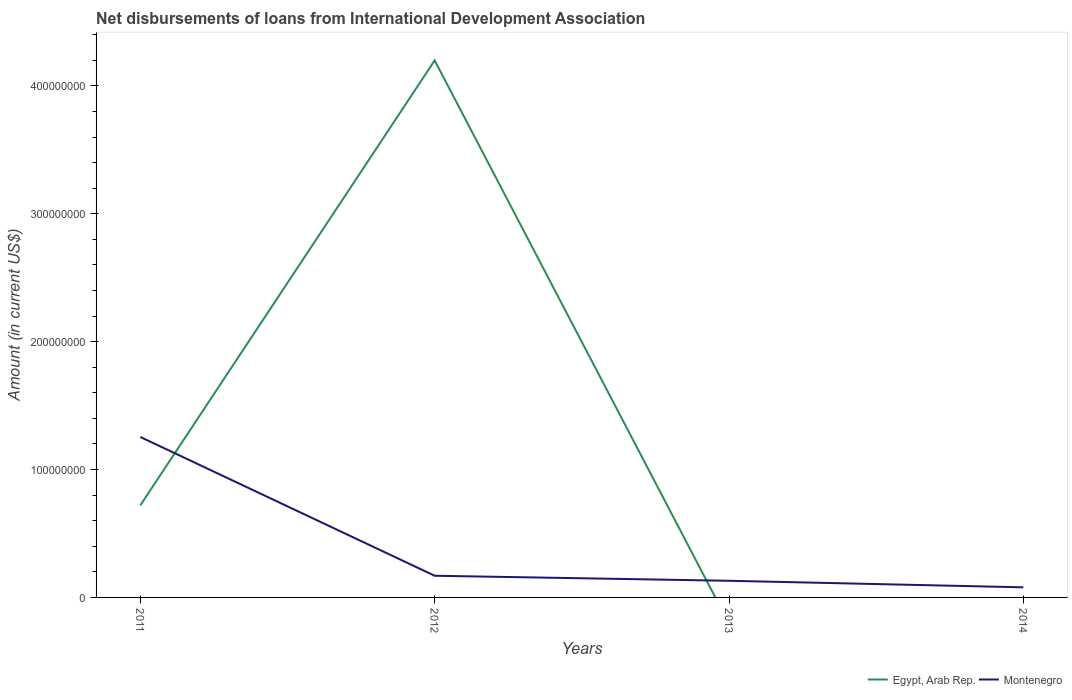How many different coloured lines are there?
Ensure brevity in your answer.  2. Does the line corresponding to Egypt, Arab Rep. intersect with the line corresponding to Montenegro?
Offer a terse response. Yes. What is the total amount of loans disbursed in Montenegro in the graph?
Your response must be concise. 5.12e+06. What is the difference between the highest and the second highest amount of loans disbursed in Egypt, Arab Rep.?
Offer a very short reply. 4.20e+08. Is the amount of loans disbursed in Montenegro strictly greater than the amount of loans disbursed in Egypt, Arab Rep. over the years?
Offer a very short reply. No. How many years are there in the graph?
Your response must be concise. 4. What is the difference between two consecutive major ticks on the Y-axis?
Your answer should be very brief. 1.00e+08. Are the values on the major ticks of Y-axis written in scientific E-notation?
Your response must be concise. No. How are the legend labels stacked?
Offer a very short reply. Horizontal. What is the title of the graph?
Your answer should be very brief. Net disbursements of loans from International Development Association. Does "Spain" appear as one of the legend labels in the graph?
Keep it short and to the point. No. What is the label or title of the Y-axis?
Provide a short and direct response. Amount (in current US$). What is the Amount (in current US$) in Egypt, Arab Rep. in 2011?
Make the answer very short. 7.20e+07. What is the Amount (in current US$) in Montenegro in 2011?
Your response must be concise. 1.25e+08. What is the Amount (in current US$) of Egypt, Arab Rep. in 2012?
Your answer should be very brief. 4.20e+08. What is the Amount (in current US$) in Montenegro in 2012?
Offer a terse response. 1.70e+07. What is the Amount (in current US$) in Egypt, Arab Rep. in 2013?
Keep it short and to the point. 0. What is the Amount (in current US$) in Montenegro in 2013?
Offer a very short reply. 1.30e+07. What is the Amount (in current US$) in Egypt, Arab Rep. in 2014?
Provide a succinct answer. 0. What is the Amount (in current US$) of Montenegro in 2014?
Provide a succinct answer. 7.89e+06. Across all years, what is the maximum Amount (in current US$) of Egypt, Arab Rep.?
Ensure brevity in your answer.  4.20e+08. Across all years, what is the maximum Amount (in current US$) of Montenegro?
Provide a succinct answer. 1.25e+08. Across all years, what is the minimum Amount (in current US$) of Montenegro?
Offer a terse response. 7.89e+06. What is the total Amount (in current US$) of Egypt, Arab Rep. in the graph?
Provide a short and direct response. 4.92e+08. What is the total Amount (in current US$) of Montenegro in the graph?
Ensure brevity in your answer.  1.63e+08. What is the difference between the Amount (in current US$) of Egypt, Arab Rep. in 2011 and that in 2012?
Your answer should be very brief. -3.48e+08. What is the difference between the Amount (in current US$) in Montenegro in 2011 and that in 2012?
Give a very brief answer. 1.09e+08. What is the difference between the Amount (in current US$) of Montenegro in 2011 and that in 2013?
Keep it short and to the point. 1.12e+08. What is the difference between the Amount (in current US$) of Montenegro in 2011 and that in 2014?
Give a very brief answer. 1.18e+08. What is the difference between the Amount (in current US$) in Montenegro in 2012 and that in 2013?
Give a very brief answer. 3.94e+06. What is the difference between the Amount (in current US$) in Montenegro in 2012 and that in 2014?
Your response must be concise. 9.06e+06. What is the difference between the Amount (in current US$) in Montenegro in 2013 and that in 2014?
Your response must be concise. 5.12e+06. What is the difference between the Amount (in current US$) of Egypt, Arab Rep. in 2011 and the Amount (in current US$) of Montenegro in 2012?
Ensure brevity in your answer.  5.51e+07. What is the difference between the Amount (in current US$) of Egypt, Arab Rep. in 2011 and the Amount (in current US$) of Montenegro in 2013?
Ensure brevity in your answer.  5.90e+07. What is the difference between the Amount (in current US$) in Egypt, Arab Rep. in 2011 and the Amount (in current US$) in Montenegro in 2014?
Your answer should be very brief. 6.41e+07. What is the difference between the Amount (in current US$) of Egypt, Arab Rep. in 2012 and the Amount (in current US$) of Montenegro in 2013?
Give a very brief answer. 4.07e+08. What is the difference between the Amount (in current US$) of Egypt, Arab Rep. in 2012 and the Amount (in current US$) of Montenegro in 2014?
Ensure brevity in your answer.  4.12e+08. What is the average Amount (in current US$) in Egypt, Arab Rep. per year?
Give a very brief answer. 1.23e+08. What is the average Amount (in current US$) in Montenegro per year?
Your answer should be very brief. 4.08e+07. In the year 2011, what is the difference between the Amount (in current US$) in Egypt, Arab Rep. and Amount (in current US$) in Montenegro?
Your response must be concise. -5.34e+07. In the year 2012, what is the difference between the Amount (in current US$) of Egypt, Arab Rep. and Amount (in current US$) of Montenegro?
Make the answer very short. 4.03e+08. What is the ratio of the Amount (in current US$) in Egypt, Arab Rep. in 2011 to that in 2012?
Keep it short and to the point. 0.17. What is the ratio of the Amount (in current US$) in Montenegro in 2011 to that in 2012?
Give a very brief answer. 7.4. What is the ratio of the Amount (in current US$) in Montenegro in 2011 to that in 2013?
Provide a short and direct response. 9.64. What is the ratio of the Amount (in current US$) of Montenegro in 2011 to that in 2014?
Ensure brevity in your answer.  15.9. What is the ratio of the Amount (in current US$) of Montenegro in 2012 to that in 2013?
Your response must be concise. 1.3. What is the ratio of the Amount (in current US$) of Montenegro in 2012 to that in 2014?
Provide a succinct answer. 2.15. What is the ratio of the Amount (in current US$) of Montenegro in 2013 to that in 2014?
Keep it short and to the point. 1.65. What is the difference between the highest and the second highest Amount (in current US$) of Montenegro?
Offer a very short reply. 1.09e+08. What is the difference between the highest and the lowest Amount (in current US$) in Egypt, Arab Rep.?
Offer a terse response. 4.20e+08. What is the difference between the highest and the lowest Amount (in current US$) of Montenegro?
Your response must be concise. 1.18e+08. 